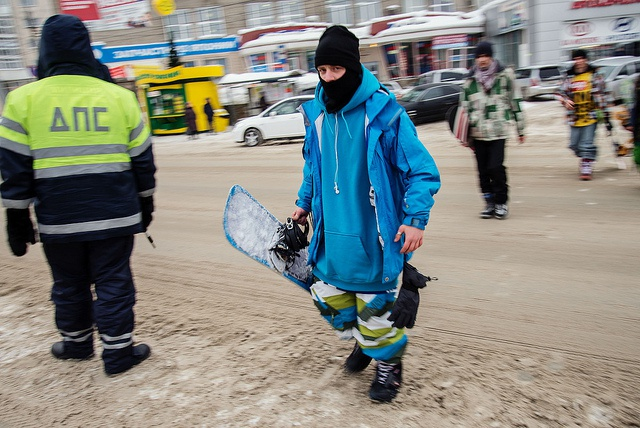Describe the objects in this image and their specific colors. I can see people in darkgray, black, lightgreen, and gray tones, people in darkgray, teal, black, and navy tones, people in darkgray, black, and gray tones, snowboard in darkgray, lightgray, and black tones, and people in darkgray, gray, black, and maroon tones in this image. 